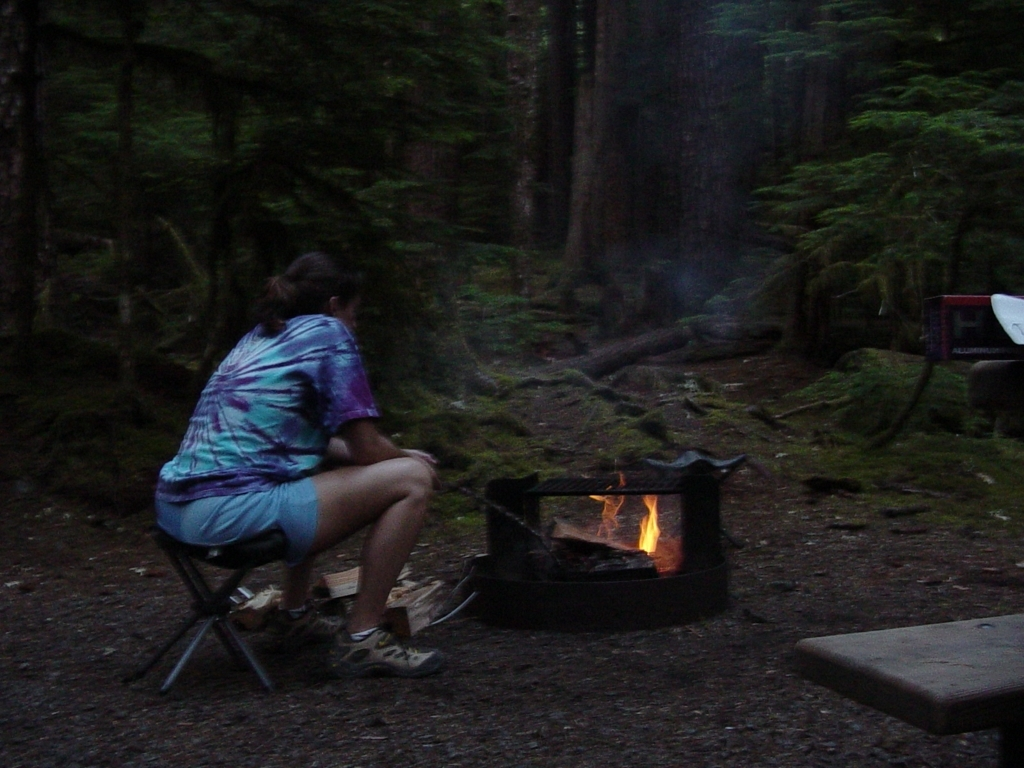What activities do the surroundings imply the person might be engaged in or have engaged in? The surroundings suggest that the person might be engaging in typical camping activities, such as preparing for a campfire meal, enjoying some quiet time connecting with nature, or perhaps winding down after a day of hiking and exploring the dense forest environment. 